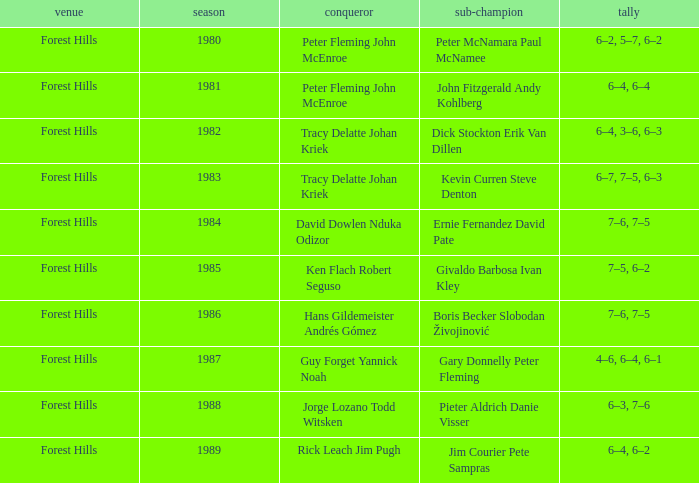Who were the champions in 1988? Jorge Lozano Todd Witsken. 